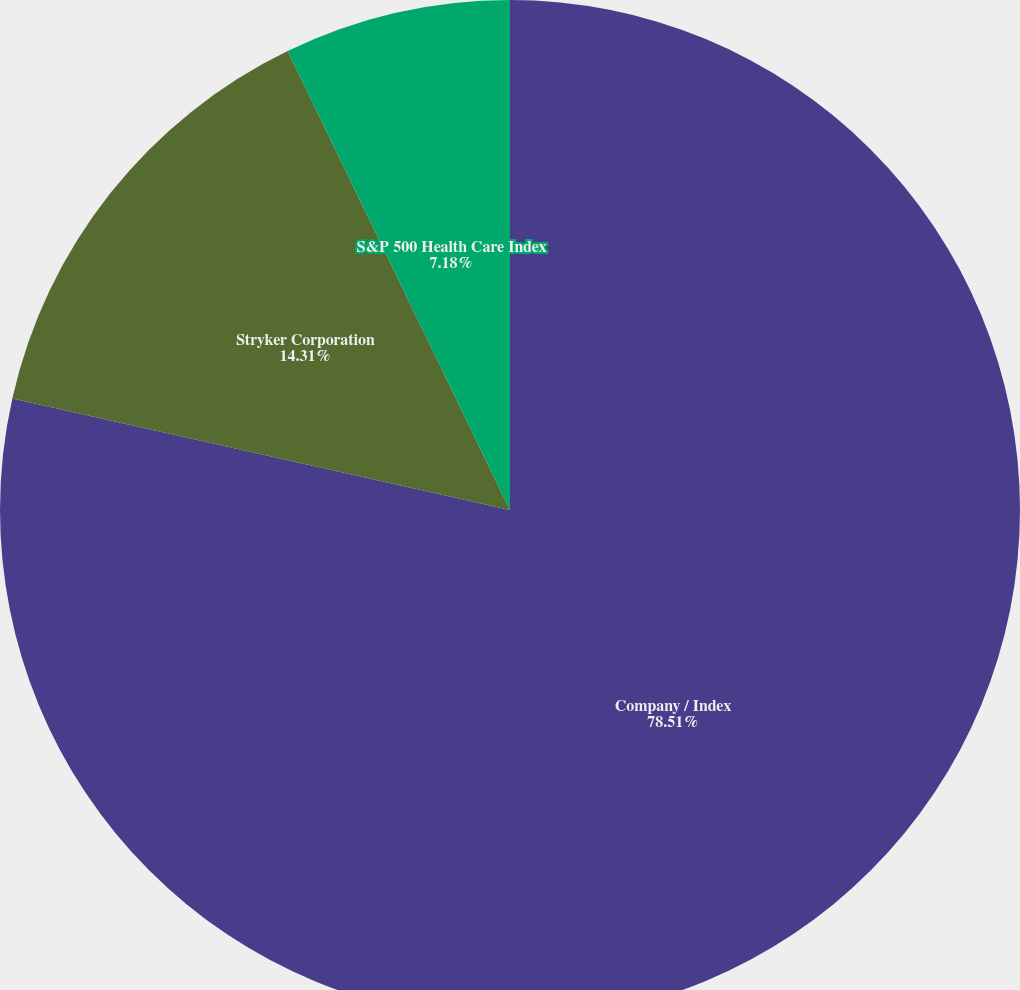<chart> <loc_0><loc_0><loc_500><loc_500><pie_chart><fcel>Company / Index<fcel>Stryker Corporation<fcel>S&P 500 Health Care Index<nl><fcel>78.5%<fcel>14.31%<fcel>7.18%<nl></chart> 